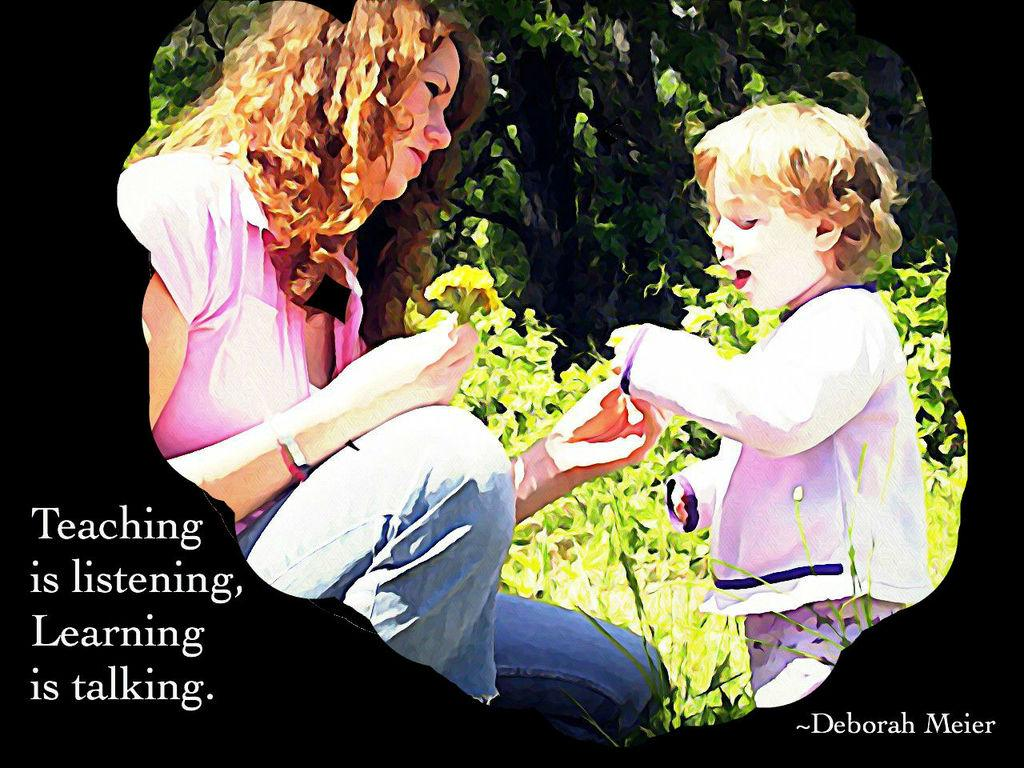What is depicted on the poster in the image? The poster contains a woman and a kid, along with trees. Where is the text located on the poster? The text is on the left side of the poster. What type of grain is being harvested by the woman and kid in the poster? There is no grain present in the poster; it features a woman and a kid with trees. What decision is the woman making in the poster? There is no decision-making process depicted in the poster; it simply shows a woman and a kid with trees. 